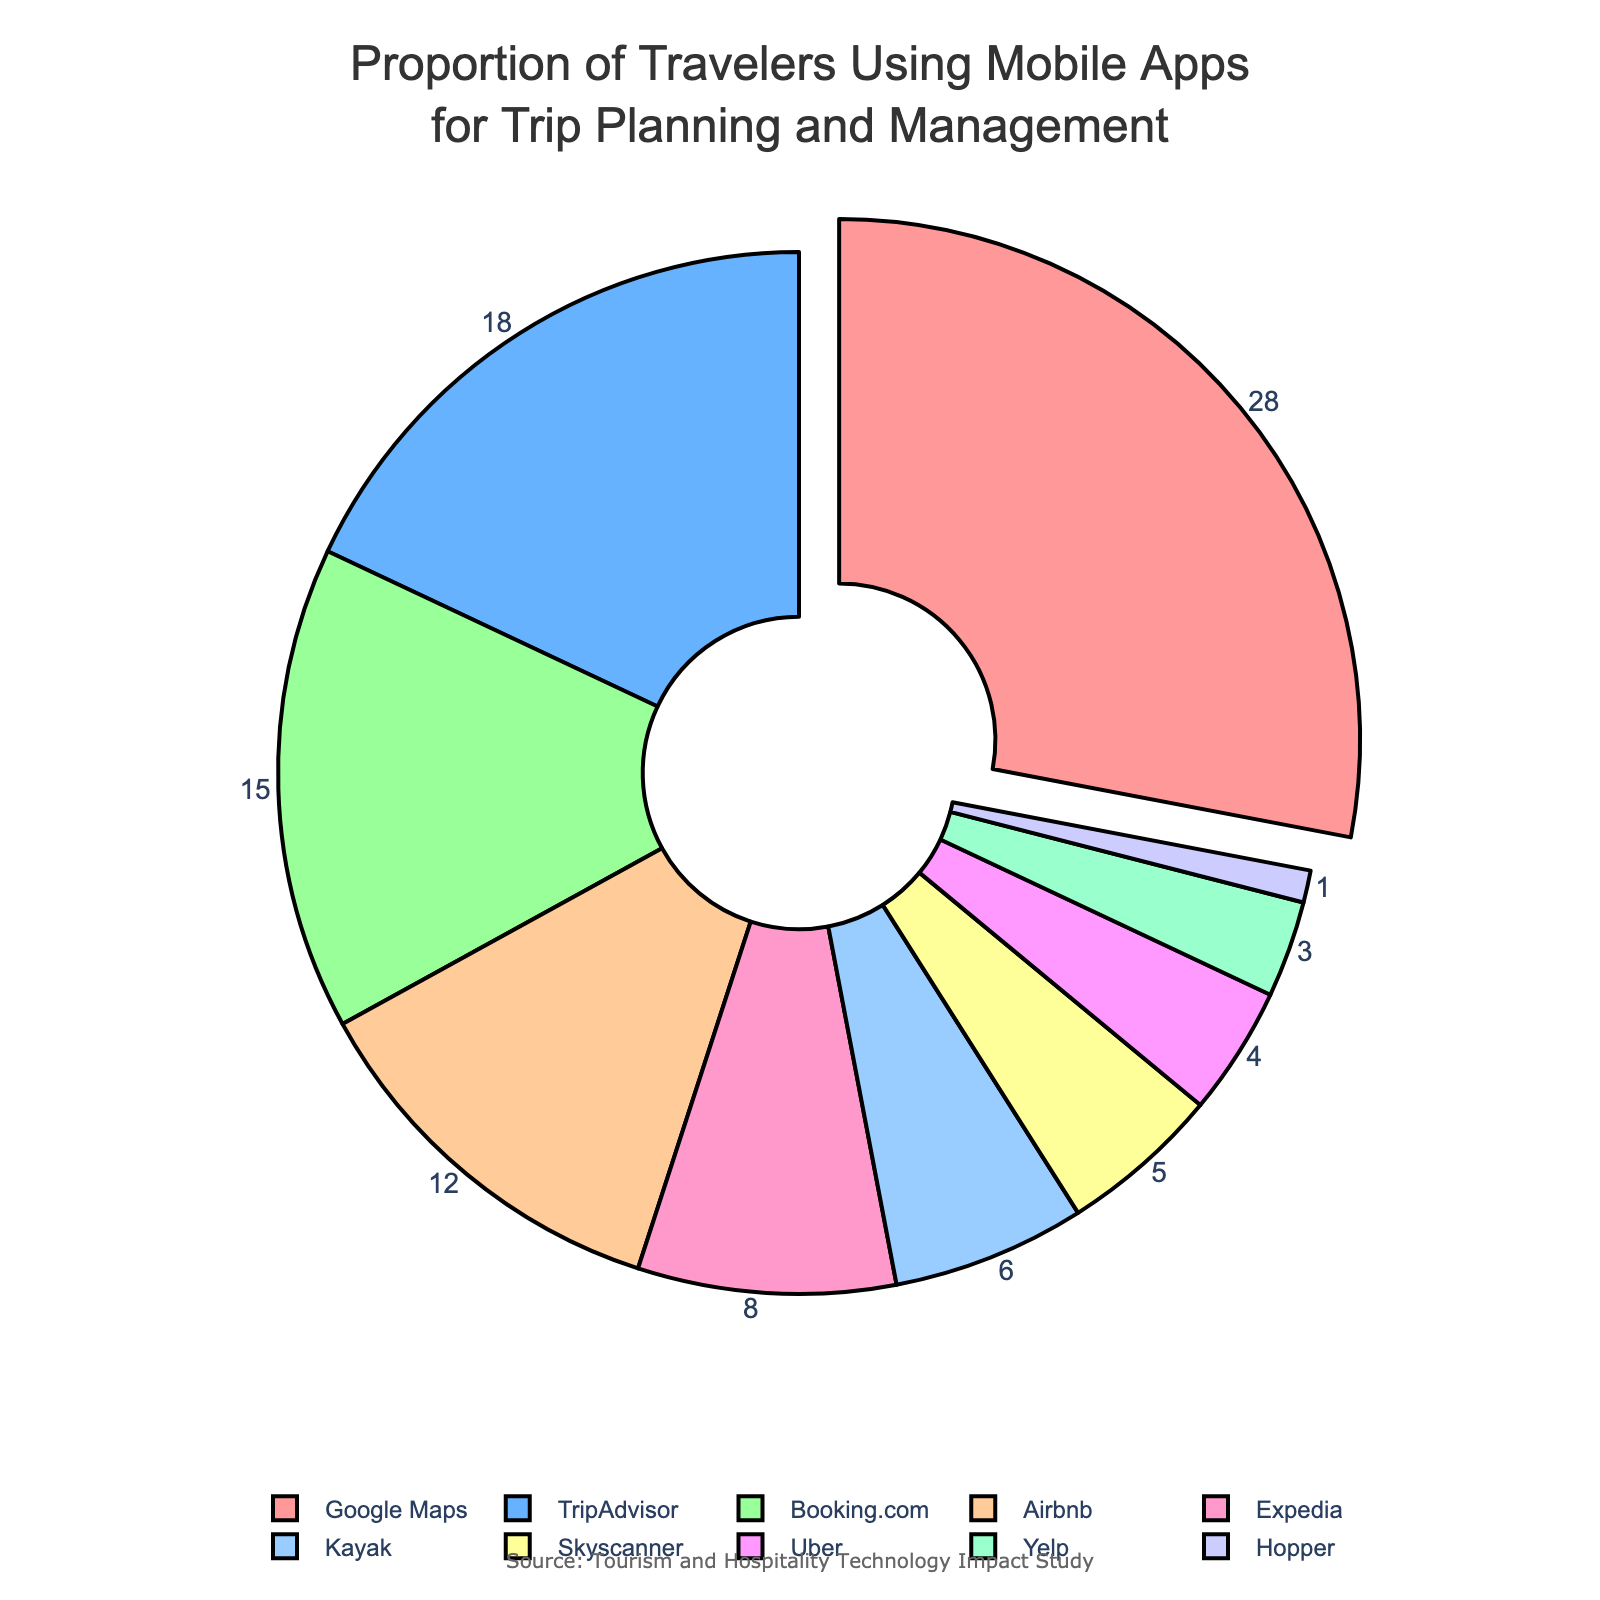What is the percentage of travelers using Google Maps compared to TripAdvisor? The pie chart shows Google Maps has 28% and TripAdvisor has 18%. The difference is 28% - 18% = 10%.
Answer: 10% Which app has the smallest proportion of users? The pie chart reveals that Hopper has the smallest proportion of users with 1%.
Answer: Hopper What is the combined percentage of travelers using Booking.com and Airbnb? Adding the two percentages together gives 15% + 12% = 27%.
Answer: 27% Which apps have a usage proportion greater than 10%? The apps with proportions greater than 10% are Google Maps (28%), TripAdvisor (18%), Booking.com (15%), and Airbnb (12%).
Answer: Google Maps, TripAdvisor, Booking.com, Airbnb What is the proportion of travelers using mobile apps other than Google Maps? Subtract Google's percentage from 100% gives 100% - 28% = 72%.
Answer: 72% What is the difference in percentage between Uber and Yelp? Uber has 4% and Yelp has 3%, so the difference is 4% - 3% = 1%.
Answer: 1% Which app is represented with the second-largest segment in the pie chart? The second-largest segment corresponds to TripAdvisor at 18%.
Answer: TripAdvisor How do the top three mobile apps compare in terms of user proportion? The top three apps are Google Maps (28%), TripAdvisor (18%), and Booking.com (15%). Comparatively, Google Maps holds the largest share, followed by TripAdvisor and then Booking.com.
Answer: Google Maps > TripAdvisor > Booking.com What is the cumulative percentage of the bottom five apps? The percentages are Expedia (8%), Kayak (6%), Skyscanner (5%), Uber (4%), and Yelp (3%). Summing these, we get 8% + 6% + 5% + 4% + 3% = 26%.
Answer: 26% What proportion of travelers uses apps that are not TripAdvisor, Booking.com, or Airbnb? Adding percentages for TripAdvisor (18%), Booking.com (15%), and Airbnb (12%) gives 18% + 15% + 12% = 45%. Subtract this from 100% to get 100% - 45% = 55%.
Answer: 55% 